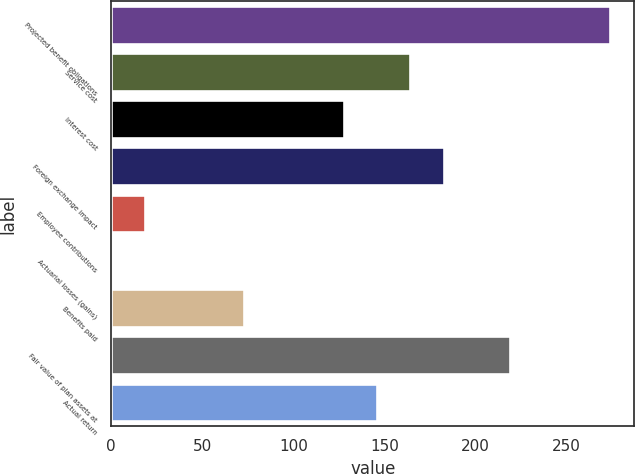Convert chart. <chart><loc_0><loc_0><loc_500><loc_500><bar_chart><fcel>Projected benefit obligations<fcel>Service cost<fcel>Interest cost<fcel>Foreign exchange impact<fcel>Employee contributions<fcel>Actuarial losses (gains)<fcel>Benefits paid<fcel>Fair value of plan assets at<fcel>Actual return<nl><fcel>273.5<fcel>164.18<fcel>127.74<fcel>182.4<fcel>18.42<fcel>0.2<fcel>73.08<fcel>218.84<fcel>145.96<nl></chart> 